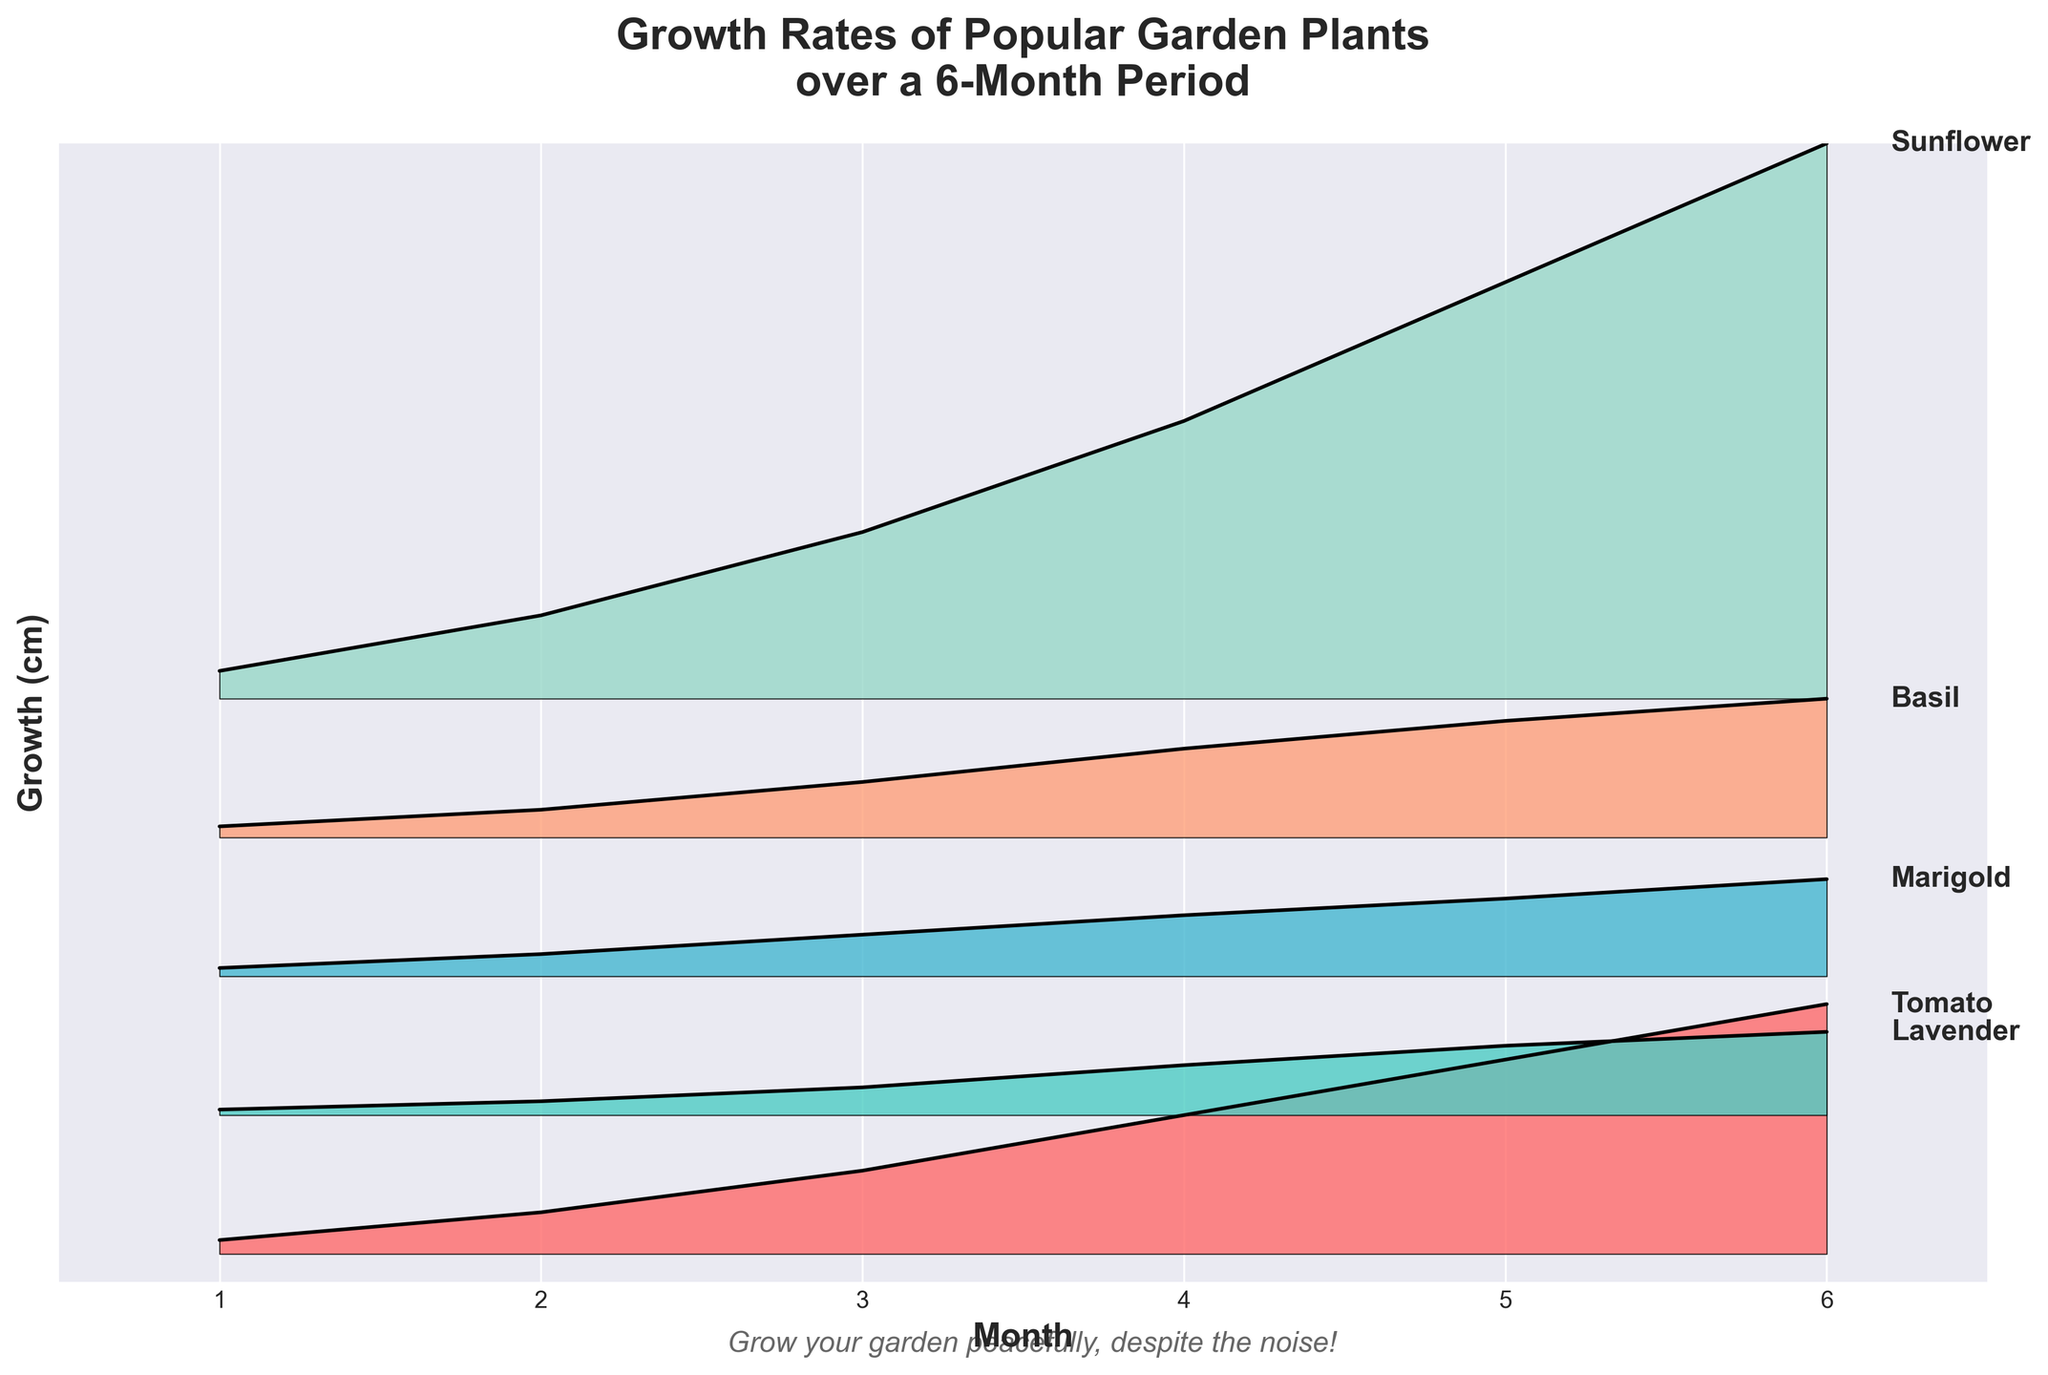Which plant shows the highest growth by month 6? By observing the last point in month 6 for all plants, we see that Sunflower reaches 200 cm, which is the highest growth among the plants.
Answer: Sunflower Which plant has the lowest growth in month 1? By observing the growth values in month 1, Lavender has the lowest growth at 2 cm.
Answer: Lavender What is the total growth of Marigold from month 1 to month 3? The growth values for Marigold from month 1 to month 3 are 3, 8, and 15 cm. Adding these values: 3 + 8 + 15 = 26.
Answer: 26 cm Which plant shows the most significant increase in growth between month 4 and month 5? By examining the increment between month 4 and month 5 for each plant, Sunflower grows from 100 cm to 150 cm, showing an increase of 50 cm, which is the most significant.
Answer: Sunflower Are there any plants whose growth appears to be linear? By observing the plots, growth for Lavender looks approximately linear. Each month's increase seems to be consistent.
Answer: Lavender Compare the growth in month 3 of Tomato and Sunflower. Which is greater and by how much? Tomato's growth in month 3 is 30 cm, and Sunflower's growth in month 3 is 60 cm. The difference is 60 - 30 = 30 cm.
Answer: Sunflower by 30 cm Which plants have a growth value of exactly 50 cm at any month? By examining the plots, Tomato, Basil, and Sunflower have a growth of exactly 50 cm at different months.
Answer: Tomato, Basil, Sunflower What is the average growth rate of Basil from month 1 to month 6? Basil's growth values are 4, 10, 20, 32, 42, 50. Average growth rate = (4 + 10 + 20 + 32 + 42 + 50) / 6 = 158 / 6 ≈ 26.33 cm/month
Answer: ~26.33 cm/month What is the difference between the maximum growths of Tomato and Lavender in month 6? Tomato's growth in month 6 is 90 cm, and Lavender's growth in month 6 is 30 cm. The difference is 90 - 30 = 60 cm.
Answer: 60 cm 